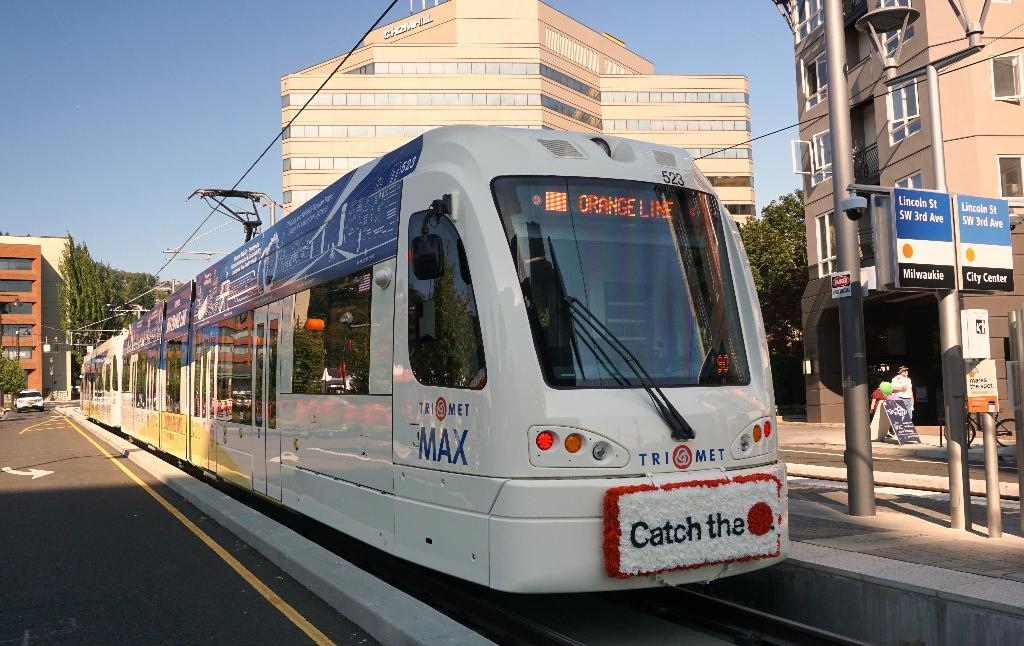What is the main subject of the image? The main subject of the image is a train. Can you describe the train's appearance? The train is white in color. Where is the train located in the image? The train is on a track. What can be seen in the background of the image? There are buildings, trees, and the sky visible in the background of the image. Can you describe the colors of the buildings in the background? The buildings are in brown and cream colors. What color are the trees in the background? The trees are green in color. What color is the sky in the background? The sky is blue in color. What type of flowers are growing on the train in the image? There are no flowers growing on the train in the image; it is a white train on a track. 